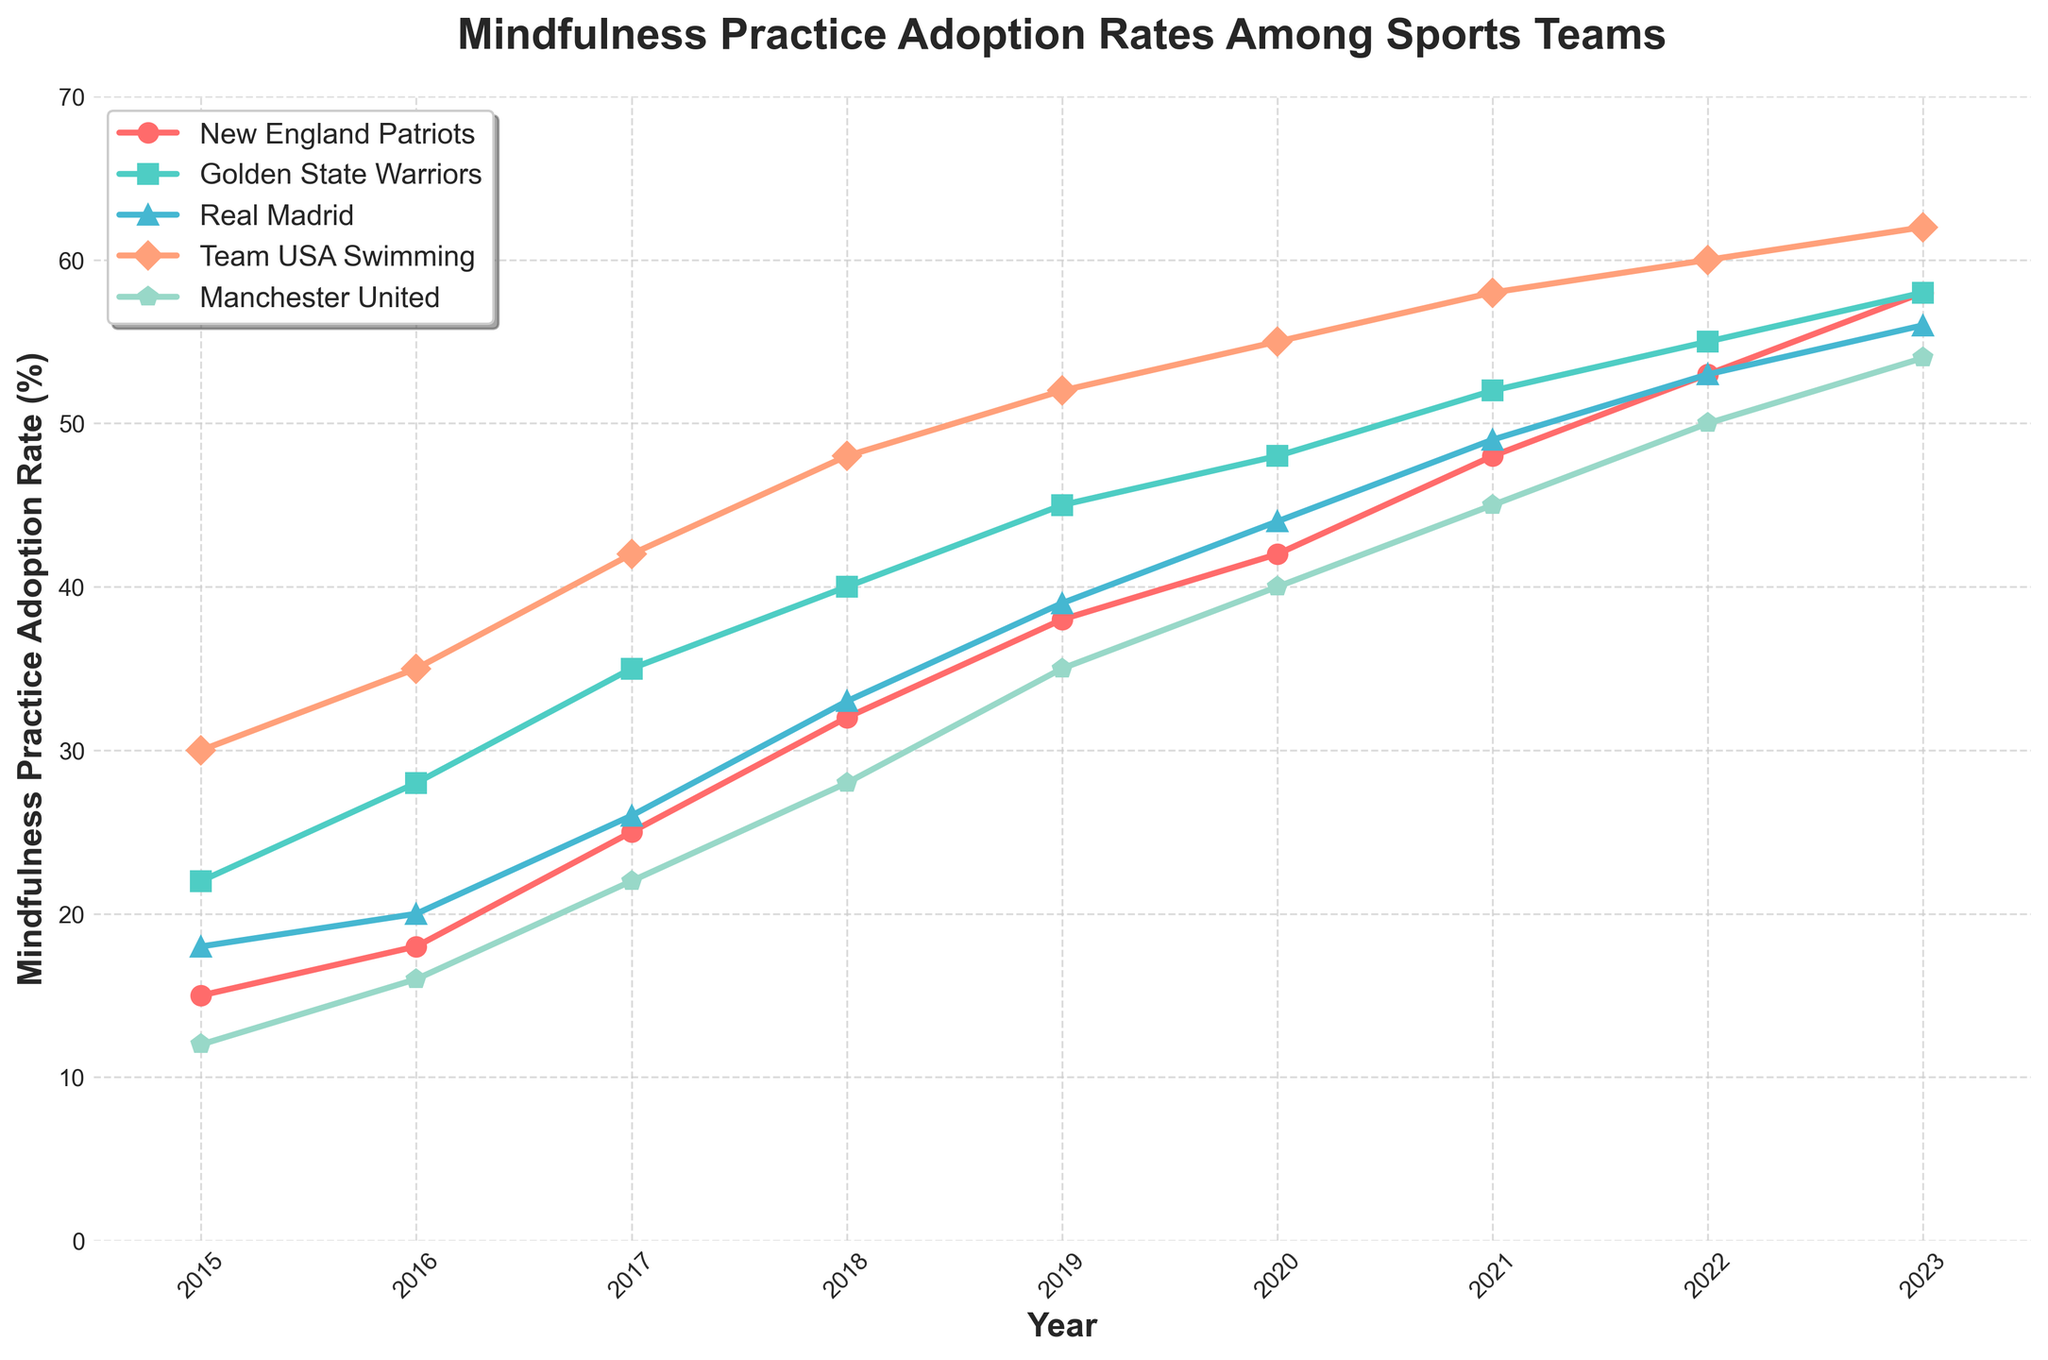What year saw the highest adoption rate of mindfulness practices for the Golden State Warriors? To find the highest adoption rate for the Golden State Warriors, look for the peak value in their line plot within the given years. The plot shows the highest rate in 2023.
Answer: 2023 Which team had the lowest adoption rate of mindfulness practices in 2019? Identify the points corresponding to the year 2019 for each team and compare their values. The New England Patriots had the lowest rate at 38%.
Answer: New England Patriots By how much did the mindfulness practice adoption rate increase for Team USA Swimming from 2017 to 2021? Calculate the difference between the 2021 and 2017 values for Team USA Swimming. The adoption rate in 2021 is 58%, and in 2017 it was 42%. Thus, the increase is 58 - 42 = 16%.
Answer: 16% Which two teams had the most similar adoption rates of mindfulness practices in the year 2022? Compare the 2022 adoption rates for all teams and find the closest values. The closest values are for Golden State Warriors (55%) and Real Madrid (53%), with only a 2% difference.
Answer: Golden State Warriors and Real Madrid What is the average adoption rate for mindfulness practices across the five teams in 2020? Sum the adoption rates of all five teams in 2020 and divide by the number of teams. The rates are 42, 48, 44, 55, and 40, summing up to 229. Dividing by 5 gives the average: 229 / 5 = 45.8%.
Answer: 45.8% Which team had the most consistent year-on-year increase in mindfulness practice adoption rates? Examine the line trends for each team and identify the one with the most steady and linear increase. Team USA Swimming shows a uniform and steady yearly increase across all years.
Answer: Team USA Swimming How much higher was the adoption rate of mindfulness practices for Real Madrid compared to Manchester United in 2018? Find the 2018 values for Real Madrid (33%) and Manchester United (28%). Subtract the lower value from the higher one: 33 - 28 = 5%.
Answer: 5% What is the difference between the highest and lowest adoption rates seen across any team in 2023? Identify the highest and lowest values in 2023 and calculate their difference. The highest rate is 62% (Team USA Swimming), and the lowest is 54% (Manchester United). The difference is: 62 - 54 = 8%.
Answer: 8% 